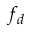Convert formula to latex. <formula><loc_0><loc_0><loc_500><loc_500>f _ { d }</formula> 